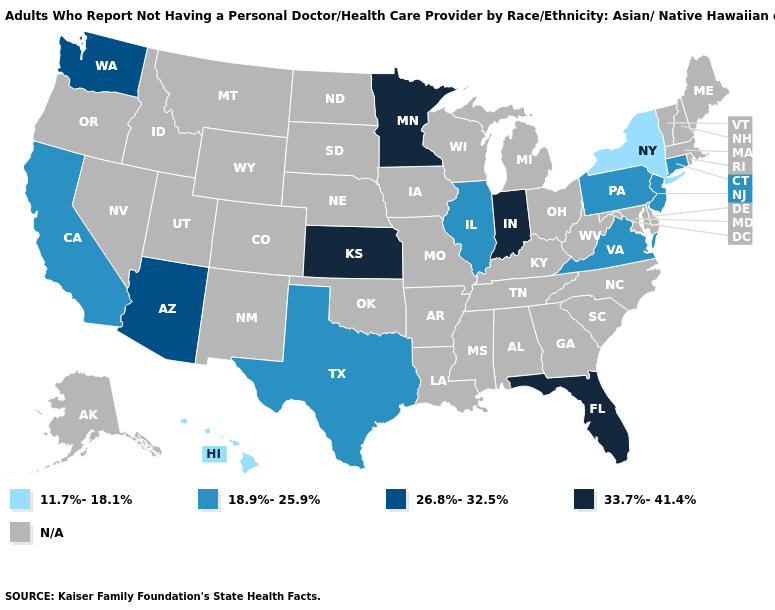Does the first symbol in the legend represent the smallest category?
Give a very brief answer. Yes. What is the value of Massachusetts?
Answer briefly. N/A. What is the value of Iowa?
Quick response, please. N/A. Which states hav the highest value in the Northeast?
Keep it brief. Connecticut, New Jersey, Pennsylvania. Name the states that have a value in the range 18.9%-25.9%?
Be succinct. California, Connecticut, Illinois, New Jersey, Pennsylvania, Texas, Virginia. Name the states that have a value in the range 18.9%-25.9%?
Keep it brief. California, Connecticut, Illinois, New Jersey, Pennsylvania, Texas, Virginia. How many symbols are there in the legend?
Write a very short answer. 5. Does the map have missing data?
Give a very brief answer. Yes. Does the first symbol in the legend represent the smallest category?
Short answer required. Yes. Does New York have the highest value in the Northeast?
Keep it brief. No. Does the map have missing data?
Answer briefly. Yes. What is the value of Hawaii?
Write a very short answer. 11.7%-18.1%. Which states have the lowest value in the USA?
Keep it brief. Hawaii, New York. Name the states that have a value in the range 33.7%-41.4%?
Be succinct. Florida, Indiana, Kansas, Minnesota. 